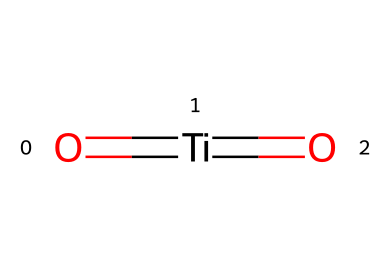How many titanium atoms are in this structure? The SMILES representation indicates a single "Ti" symbol, defining one titanium atom in the chemical structure.
Answer: one What type of bonds are present in this chemical structure? The structure includes double bonds, as indicated by the "=" sign between "Ti" and "O" (oxygen). Hence, it shows that Ti is double bonded to two oxygen atoms.
Answer: double bonds How many oxygen atoms are in this chemical structure? The SMILES representation contains two "O" symbols, indicating the presence of two oxygen atoms connected to the titanium atom.
Answer: two What is the oxidation state of titanium in this structure? In the given structure, titanium (Ti) has a formal charge balance of four, indicating that the oxidation state of titanium is typically +4 when coordinated with two oxygens in this manner.
Answer: +4 What type of solid is formed by this chemical structure? This structure represents a metal oxide, indicating that it is a type of inorganic solid typically seen in paints and coatings.
Answer: metal oxide What is the role of titanium in this paint structure? Titanium serves as a pigment and stabilizer in non-toxic paints, enhancing the opacity and durability of the painted surface.
Answer: pigment and stabilizer 